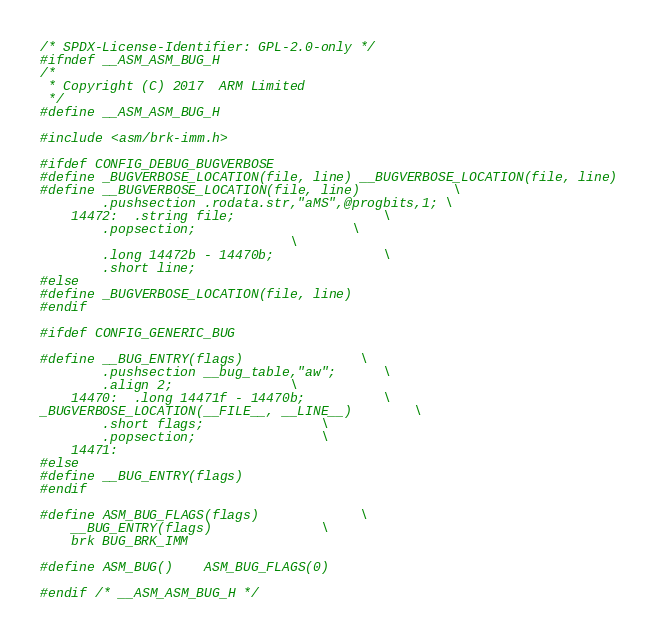Convert code to text. <code><loc_0><loc_0><loc_500><loc_500><_C_>/* SPDX-License-Identifier: GPL-2.0-only */
#ifndef __ASM_ASM_BUG_H
/*
 * Copyright (C) 2017  ARM Limited
 */
#define __ASM_ASM_BUG_H

#include <asm/brk-imm.h>

#ifdef CONFIG_DEBUG_BUGVERBOSE
#define _BUGVERBOSE_LOCATION(file, line) __BUGVERBOSE_LOCATION(file, line)
#define __BUGVERBOSE_LOCATION(file, line)			\
		.pushsection .rodata.str,"aMS",@progbits,1;	\
	14472:	.string file;					\
		.popsection;					\
								\
		.long 14472b - 14470b;				\
		.short line;
#else
#define _BUGVERBOSE_LOCATION(file, line)
#endif

#ifdef CONFIG_GENERIC_BUG

#define __BUG_ENTRY(flags) 				\
		.pushsection __bug_table,"aw";		\
		.align 2;				\
	14470:	.long 14471f - 14470b;			\
_BUGVERBOSE_LOCATION(__FILE__, __LINE__)		\
		.short flags; 				\
		.popsection;				\
	14471:
#else
#define __BUG_ENTRY(flags)
#endif

#define ASM_BUG_FLAGS(flags)				\
	__BUG_ENTRY(flags)				\
	brk	BUG_BRK_IMM

#define ASM_BUG()	ASM_BUG_FLAGS(0)

#endif /* __ASM_ASM_BUG_H */
</code> 